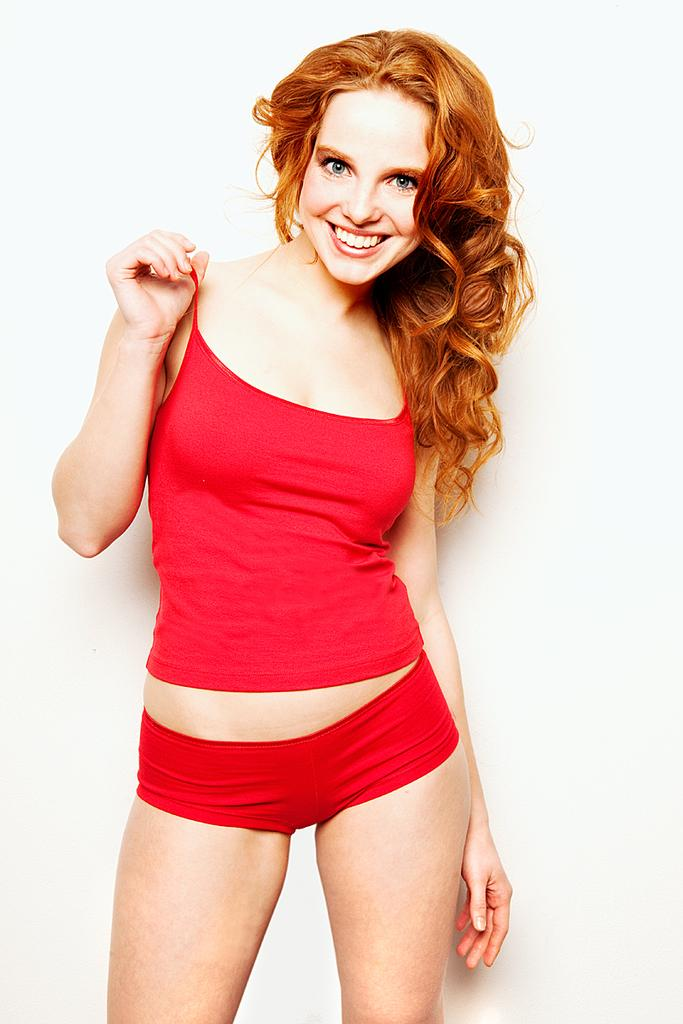Who is present in the image? There is a woman in the image. What is the woman doing in the image? The woman is standing and smiling. What might be the reason for her pose? The woman is posing for a photo. What is the color of the background in the image? The background of the image is white in color. What type of surface might the white background be? The white background appears to be a wall. Can you see any zebras in the image? No, there are no zebras present in the image. What type of cord is being used to hold the woman's smile in place? There is no cord visible in the image, and the woman's smile is not being held in place by any external force. 